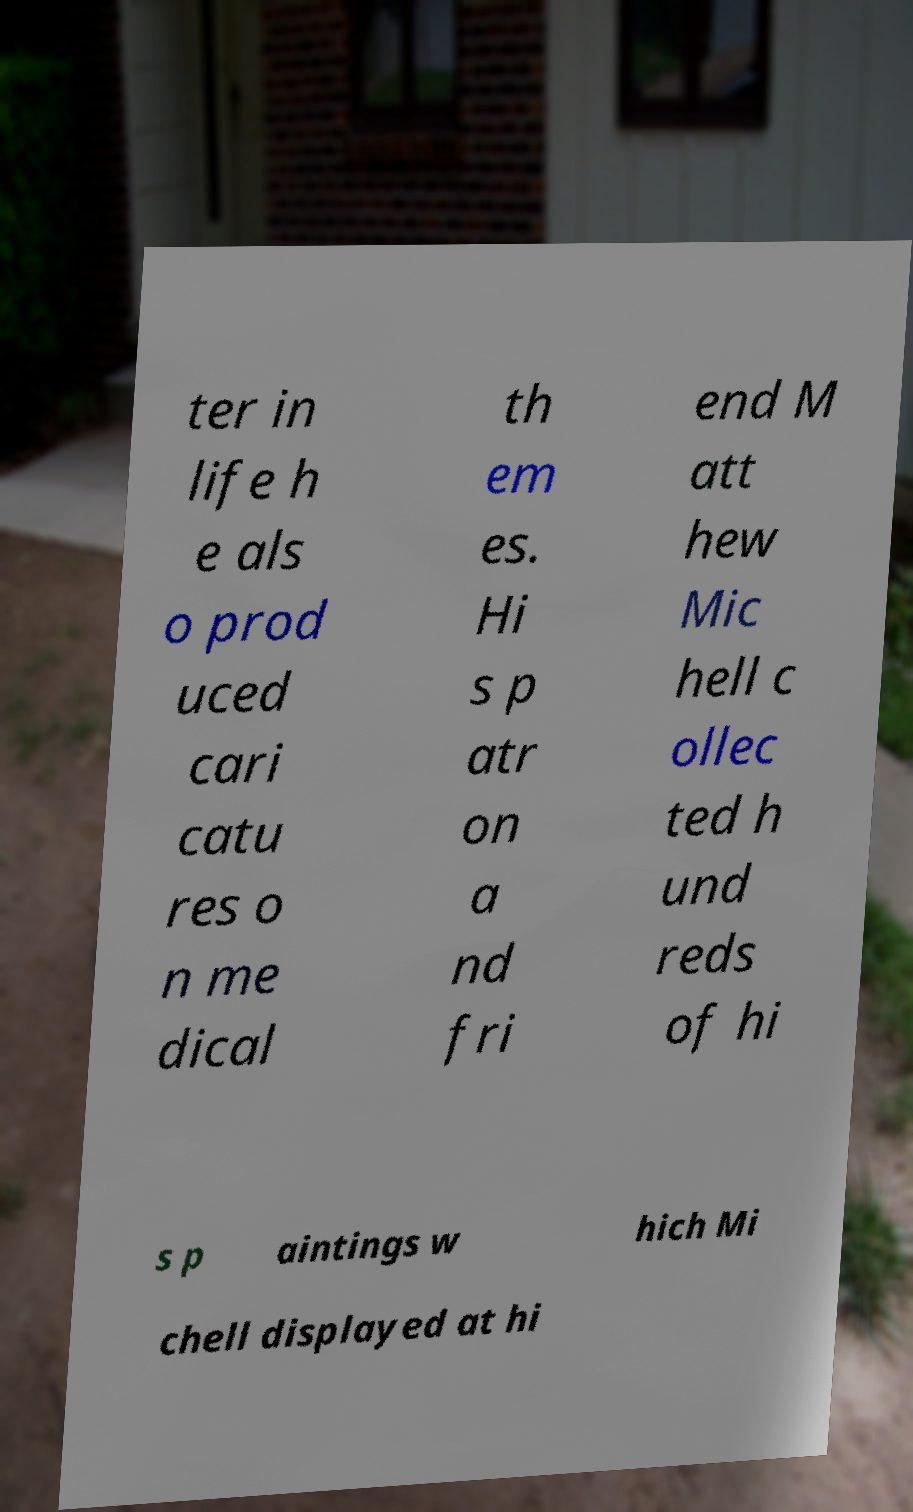There's text embedded in this image that I need extracted. Can you transcribe it verbatim? ter in life h e als o prod uced cari catu res o n me dical th em es. Hi s p atr on a nd fri end M att hew Mic hell c ollec ted h und reds of hi s p aintings w hich Mi chell displayed at hi 